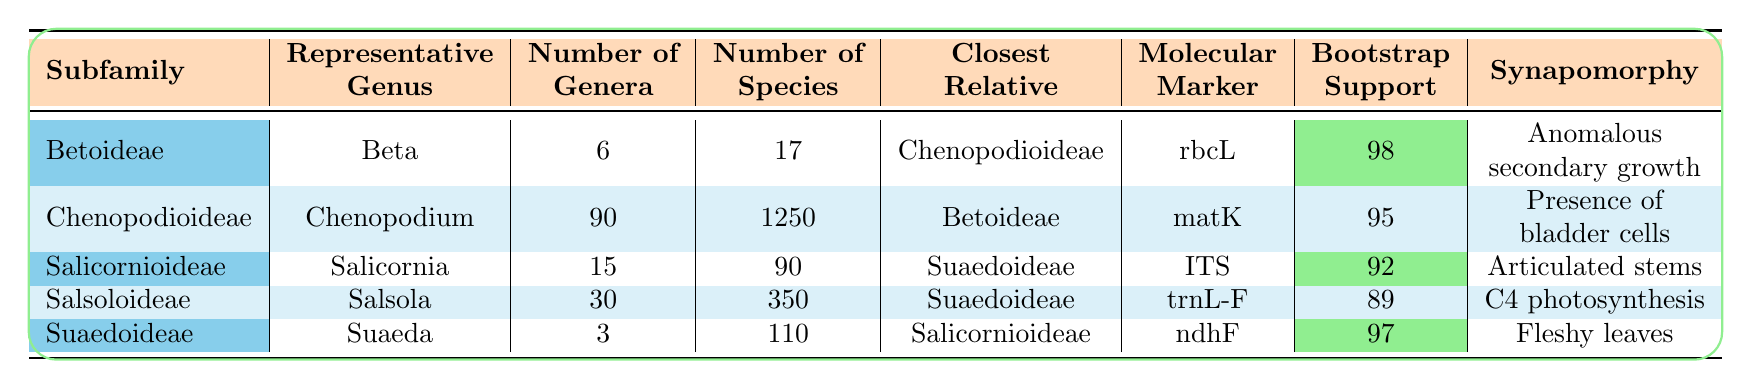What is the representative genus of the Chenopodioideae subfamily? The table explicitly states that the representative genus of the Chenopodioideae subfamily is Chenopodium.
Answer: Chenopodium How many genera are there in the Salicornioideae subfamily? According to the table, the number of genera in the Salicornioideae subfamily is 15.
Answer: 15 Which subfamily has the highest number of species? The table shows that the Chenopodioideae subfamily has the highest number of species, with a total of 1250 species, compared to others.
Answer: Chenopodioideae What is the bootstrap support value for the Betoideae subfamily? The bootstrap support value for the Betoideae subfamily, as noted in the table, is 98.
Answer: 98 Is the closest relative of the Salsoloideae subfamily Suaedoideae? According to the table, the closest relative of the Salsoloideae subfamily is indeed Suaedoideae, confirming the statement as true.
Answer: True What is the total number of species across all subfamilies represented in the table? Calculating the total number of species, we have 17 (Betoideae) + 1250 (Chenopodioideae) + 90 (Salicornioideae) + 350 (Salsoloideae) + 110 (Suaedoideae) = 1817 species in total.
Answer: 1817 Which subfamily has the lowest bootstrap support? The bootstrap support values for each subfamily are 98, 95, 92, 89, and 97. The lowest value is 89 for the Salsoloideae subfamily.
Answer: Salsoloideae If you compare the number of species in Salsoloideae and Suaedoideae, which one is greater and by how much? The Salsoloideae subfamily has 350 species while Suaedoideae has 110 species. The difference is 350 - 110 = 240, meaning Salsoloideae has 240 more species.
Answer: 240 What characterizes the Betoideae subfamily as indicated by its synapomorphy? The table indicates that the synapomorphy of the Betoideae subfamily is anomalous secondary growth, defining a unique characteristic.
Answer: Anomalous secondary growth Which subfamily has the least number of genera, and what is the count? The table indicates that Suaedoideae has the least number of genera with a count of 3, making it the subfamily with the fewest.
Answer: Suaedoideae, 3 